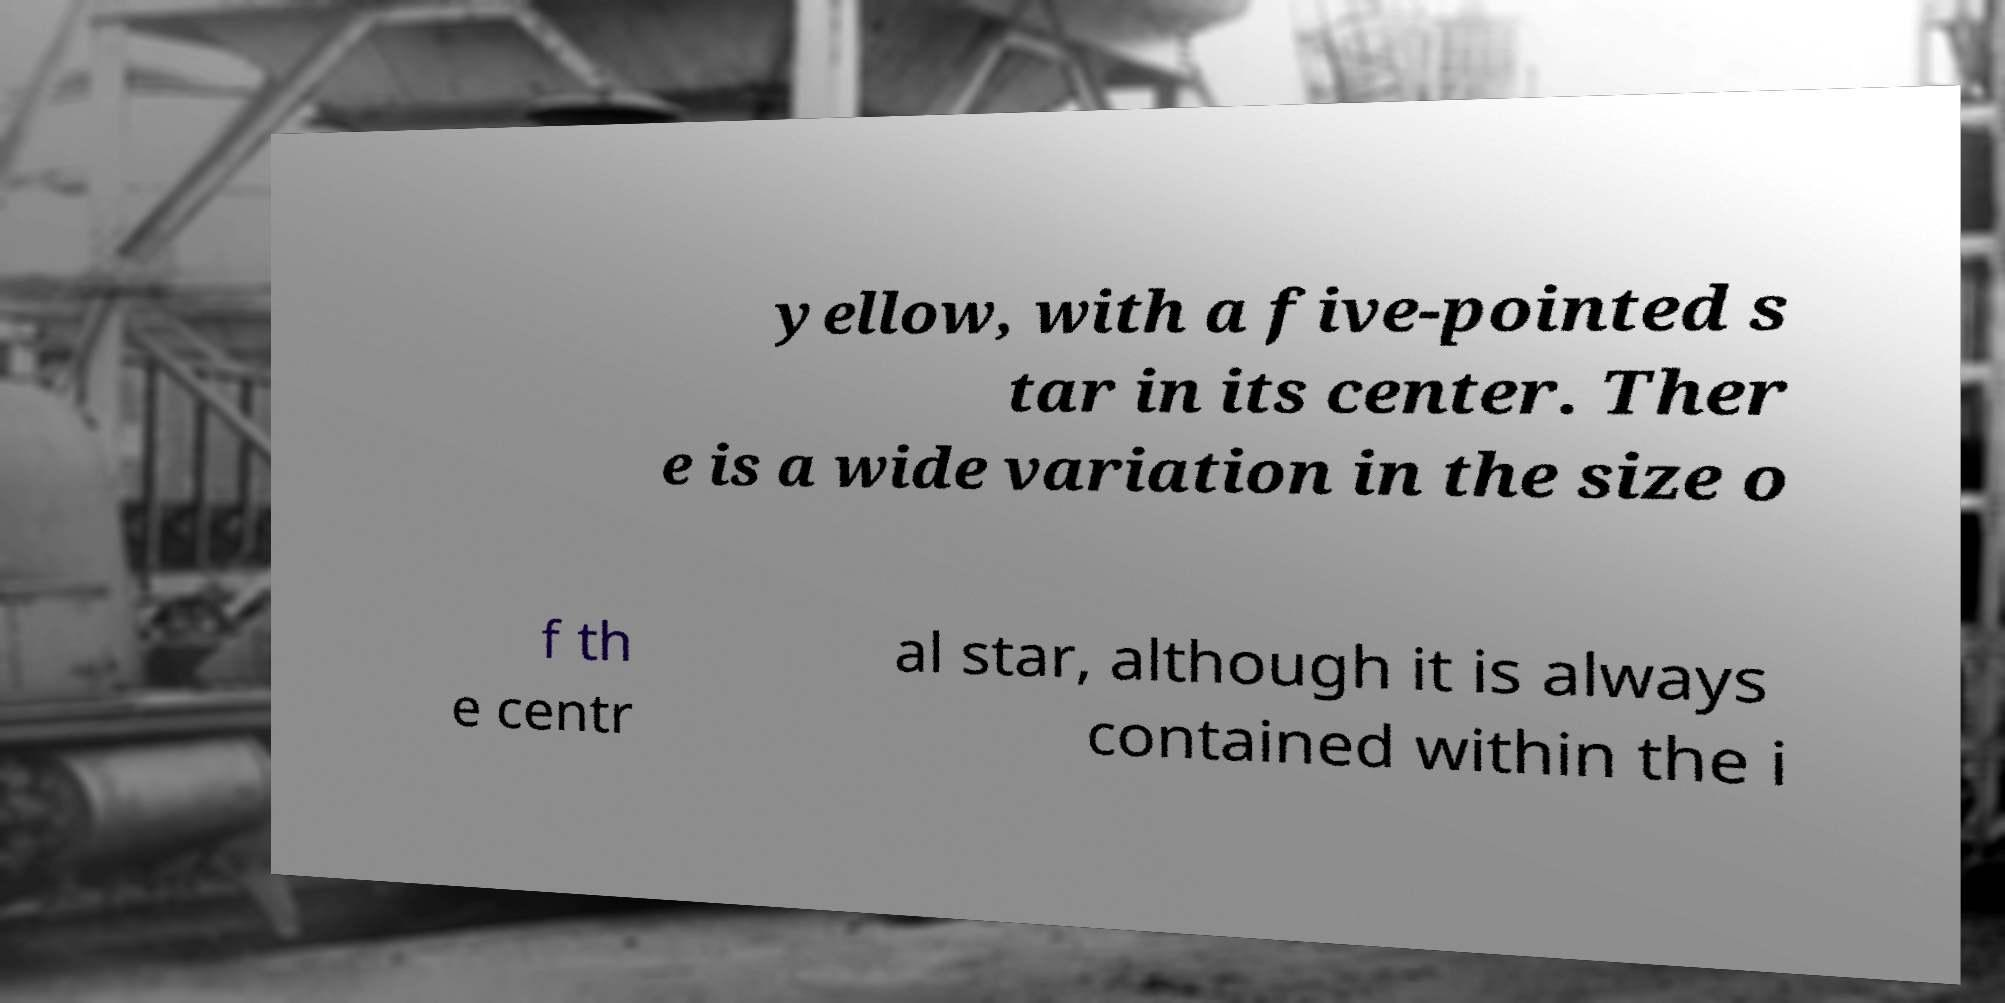Can you accurately transcribe the text from the provided image for me? yellow, with a five-pointed s tar in its center. Ther e is a wide variation in the size o f th e centr al star, although it is always contained within the i 